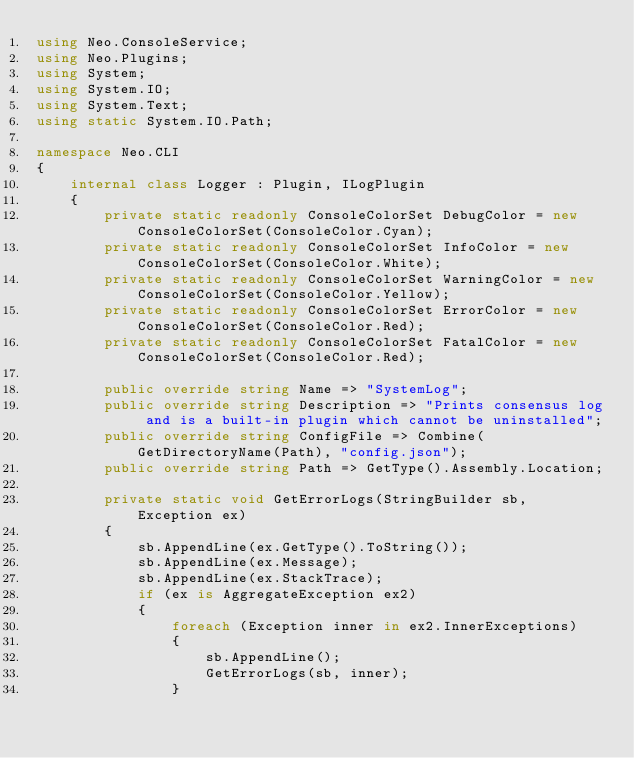<code> <loc_0><loc_0><loc_500><loc_500><_C#_>using Neo.ConsoleService;
using Neo.Plugins;
using System;
using System.IO;
using System.Text;
using static System.IO.Path;

namespace Neo.CLI
{
    internal class Logger : Plugin, ILogPlugin
    {
        private static readonly ConsoleColorSet DebugColor = new ConsoleColorSet(ConsoleColor.Cyan);
        private static readonly ConsoleColorSet InfoColor = new ConsoleColorSet(ConsoleColor.White);
        private static readonly ConsoleColorSet WarningColor = new ConsoleColorSet(ConsoleColor.Yellow);
        private static readonly ConsoleColorSet ErrorColor = new ConsoleColorSet(ConsoleColor.Red);
        private static readonly ConsoleColorSet FatalColor = new ConsoleColorSet(ConsoleColor.Red);

        public override string Name => "SystemLog";
        public override string Description => "Prints consensus log and is a built-in plugin which cannot be uninstalled";
        public override string ConfigFile => Combine(GetDirectoryName(Path), "config.json");
        public override string Path => GetType().Assembly.Location;

        private static void GetErrorLogs(StringBuilder sb, Exception ex)
        {
            sb.AppendLine(ex.GetType().ToString());
            sb.AppendLine(ex.Message);
            sb.AppendLine(ex.StackTrace);
            if (ex is AggregateException ex2)
            {
                foreach (Exception inner in ex2.InnerExceptions)
                {
                    sb.AppendLine();
                    GetErrorLogs(sb, inner);
                }</code> 